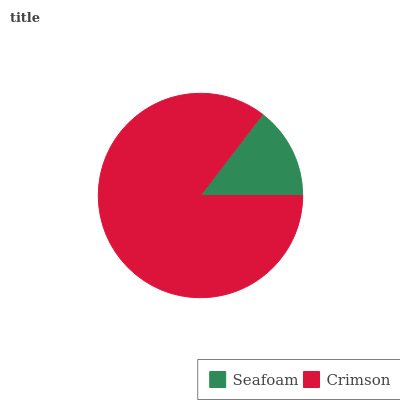Is Seafoam the minimum?
Answer yes or no. Yes. Is Crimson the maximum?
Answer yes or no. Yes. Is Crimson the minimum?
Answer yes or no. No. Is Crimson greater than Seafoam?
Answer yes or no. Yes. Is Seafoam less than Crimson?
Answer yes or no. Yes. Is Seafoam greater than Crimson?
Answer yes or no. No. Is Crimson less than Seafoam?
Answer yes or no. No. Is Crimson the high median?
Answer yes or no. Yes. Is Seafoam the low median?
Answer yes or no. Yes. Is Seafoam the high median?
Answer yes or no. No. Is Crimson the low median?
Answer yes or no. No. 